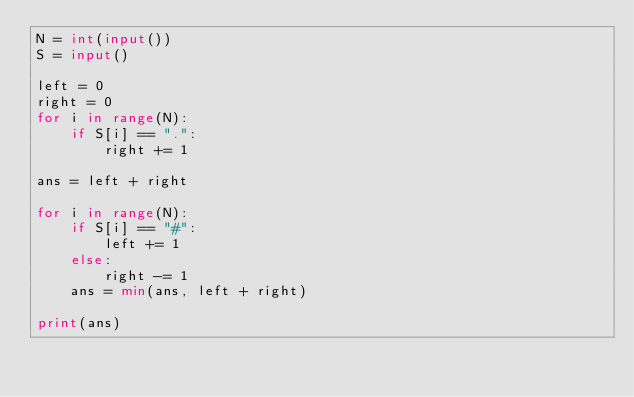Convert code to text. <code><loc_0><loc_0><loc_500><loc_500><_Python_>N = int(input())
S = input()

left = 0
right = 0
for i in range(N):
    if S[i] == ".":
        right += 1

ans = left + right

for i in range(N):
    if S[i] == "#":
        left += 1
    else:
        right -= 1
    ans = min(ans, left + right)

print(ans)
</code> 